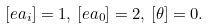Convert formula to latex. <formula><loc_0><loc_0><loc_500><loc_500>[ e a _ { i } ] = 1 , \, [ e a _ { 0 } ] = 2 , \, [ \theta ] = 0 .</formula> 